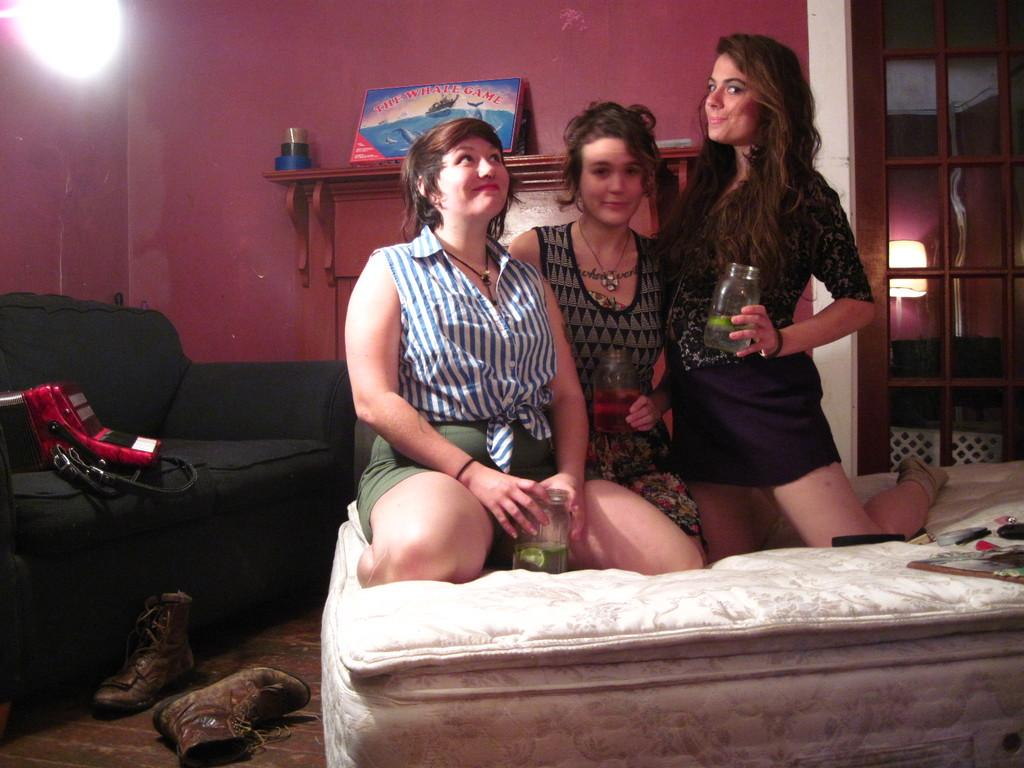What are the people in the image doing? The three people are sitting in a squat position. What are the people holding in the image? The people are holding a bottle. What can be seen in the background of the image? There is a sofa and a light in the background of the image. What type of milk is being poured from the bottle in the image? There is no indication in the image that the bottle contains milk, and therefore no such activity can be observed. 